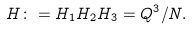Convert formula to latex. <formula><loc_0><loc_0><loc_500><loc_500>H \colon = H _ { 1 } H _ { 2 } H _ { 3 } = Q ^ { 3 } / N .</formula> 